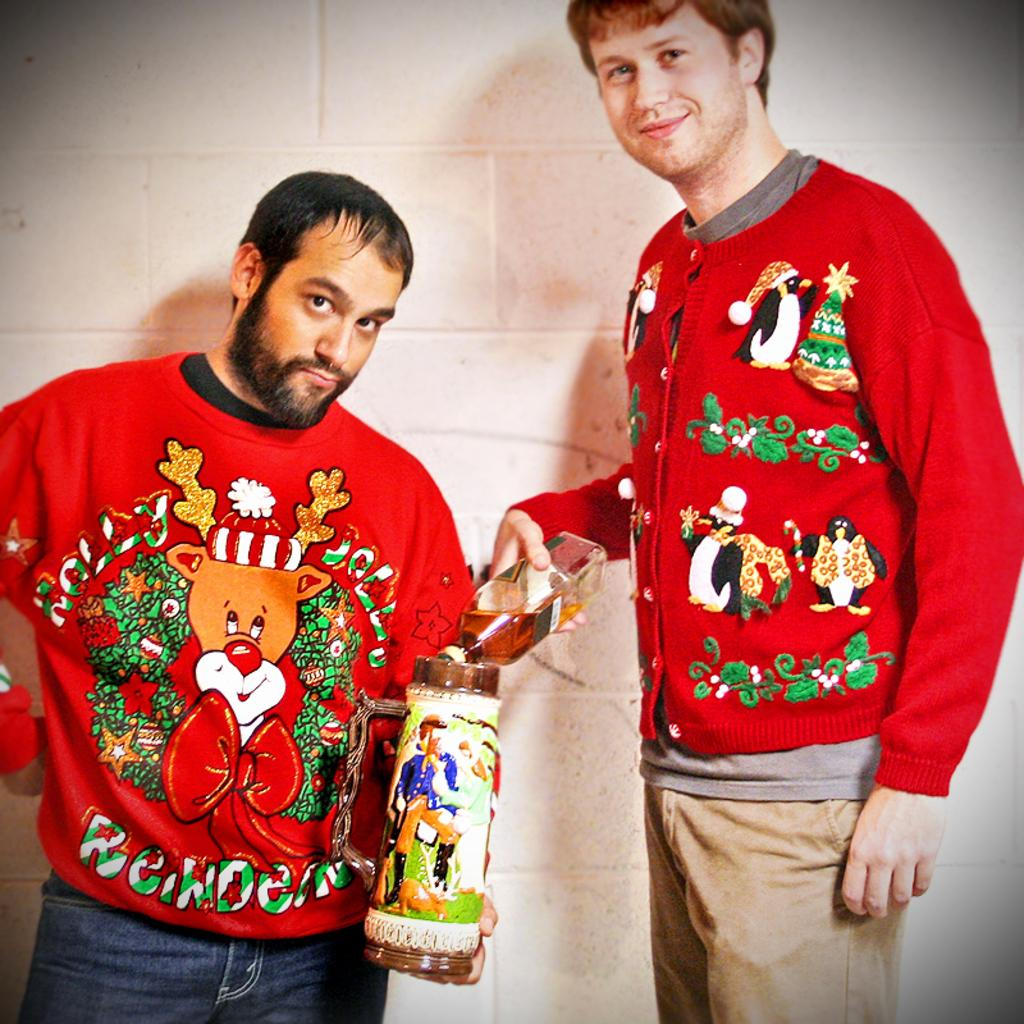How many people are present in the image? There are two persons in the image. What is one person holding in the image? One person is holding a bottle. What is the other person holding in the image? The other person is holding a tin. What type of bag can be seen in the image? There is no bag present in the image. What discovery was made by the persons in the image? The image does not depict any discovery being made by the persons. 